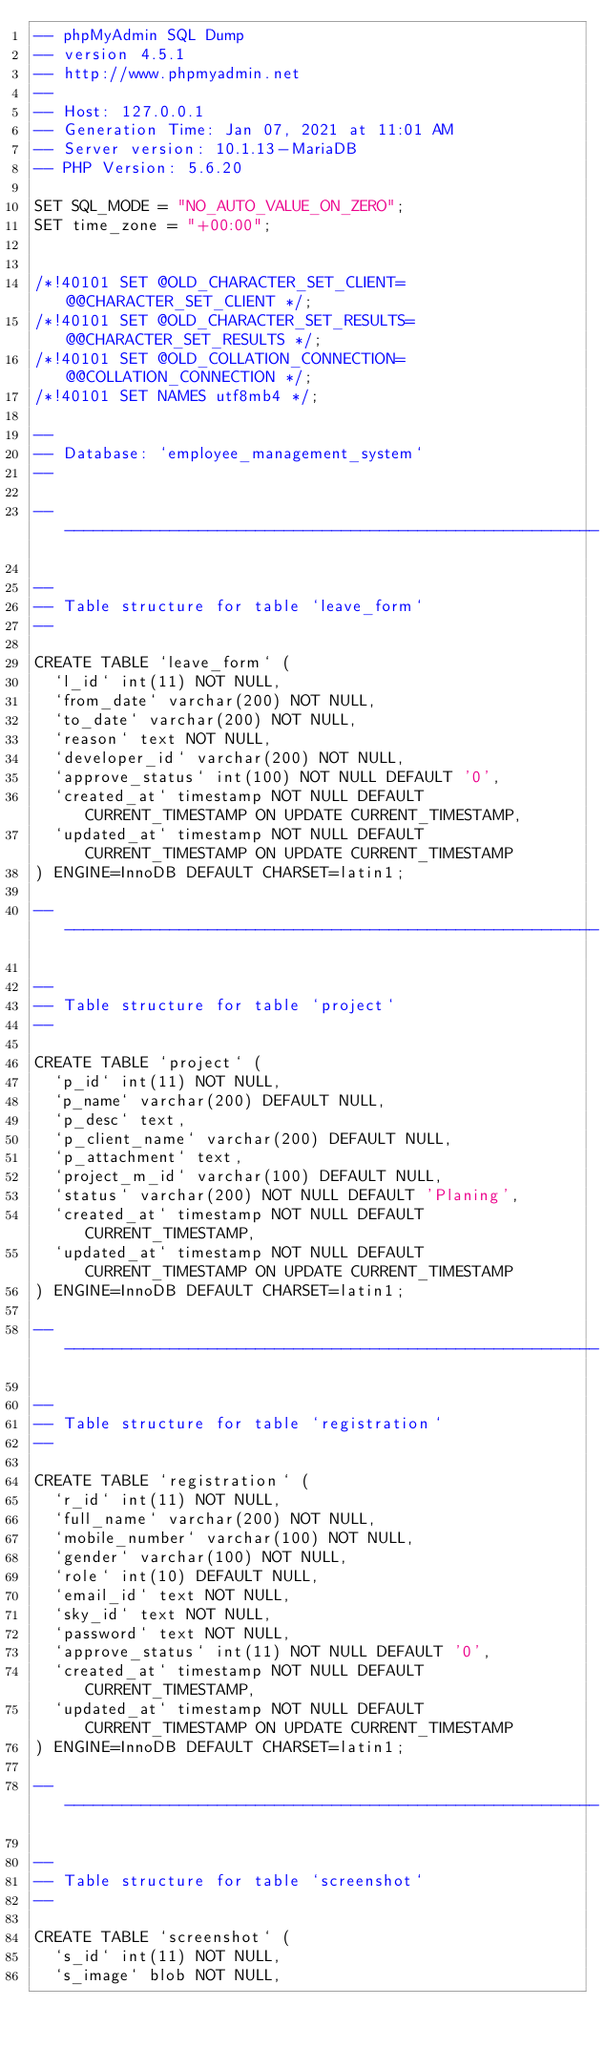Convert code to text. <code><loc_0><loc_0><loc_500><loc_500><_SQL_>-- phpMyAdmin SQL Dump
-- version 4.5.1
-- http://www.phpmyadmin.net
--
-- Host: 127.0.0.1
-- Generation Time: Jan 07, 2021 at 11:01 AM
-- Server version: 10.1.13-MariaDB
-- PHP Version: 5.6.20

SET SQL_MODE = "NO_AUTO_VALUE_ON_ZERO";
SET time_zone = "+00:00";


/*!40101 SET @OLD_CHARACTER_SET_CLIENT=@@CHARACTER_SET_CLIENT */;
/*!40101 SET @OLD_CHARACTER_SET_RESULTS=@@CHARACTER_SET_RESULTS */;
/*!40101 SET @OLD_COLLATION_CONNECTION=@@COLLATION_CONNECTION */;
/*!40101 SET NAMES utf8mb4 */;

--
-- Database: `employee_management_system`
--

-- --------------------------------------------------------

--
-- Table structure for table `leave_form`
--

CREATE TABLE `leave_form` (
  `l_id` int(11) NOT NULL,
  `from_date` varchar(200) NOT NULL,
  `to_date` varchar(200) NOT NULL,
  `reason` text NOT NULL,
  `developer_id` varchar(200) NOT NULL,
  `approve_status` int(100) NOT NULL DEFAULT '0',
  `created_at` timestamp NOT NULL DEFAULT CURRENT_TIMESTAMP ON UPDATE CURRENT_TIMESTAMP,
  `updated_at` timestamp NOT NULL DEFAULT CURRENT_TIMESTAMP ON UPDATE CURRENT_TIMESTAMP
) ENGINE=InnoDB DEFAULT CHARSET=latin1;

-- --------------------------------------------------------

--
-- Table structure for table `project`
--

CREATE TABLE `project` (
  `p_id` int(11) NOT NULL,
  `p_name` varchar(200) DEFAULT NULL,
  `p_desc` text,
  `p_client_name` varchar(200) DEFAULT NULL,
  `p_attachment` text,
  `project_m_id` varchar(100) DEFAULT NULL,
  `status` varchar(200) NOT NULL DEFAULT 'Planing',
  `created_at` timestamp NOT NULL DEFAULT CURRENT_TIMESTAMP,
  `updated_at` timestamp NOT NULL DEFAULT CURRENT_TIMESTAMP ON UPDATE CURRENT_TIMESTAMP
) ENGINE=InnoDB DEFAULT CHARSET=latin1;

-- --------------------------------------------------------

--
-- Table structure for table `registration`
--

CREATE TABLE `registration` (
  `r_id` int(11) NOT NULL,
  `full_name` varchar(200) NOT NULL,
  `mobile_number` varchar(100) NOT NULL,
  `gender` varchar(100) NOT NULL,
  `role` int(10) DEFAULT NULL,
  `email_id` text NOT NULL,
  `sky_id` text NOT NULL,
  `password` text NOT NULL,
  `approve_status` int(11) NOT NULL DEFAULT '0',
  `created_at` timestamp NOT NULL DEFAULT CURRENT_TIMESTAMP,
  `updated_at` timestamp NOT NULL DEFAULT CURRENT_TIMESTAMP ON UPDATE CURRENT_TIMESTAMP
) ENGINE=InnoDB DEFAULT CHARSET=latin1;

-- --------------------------------------------------------

--
-- Table structure for table `screenshot`
--

CREATE TABLE `screenshot` (
  `s_id` int(11) NOT NULL,
  `s_image` blob NOT NULL,</code> 